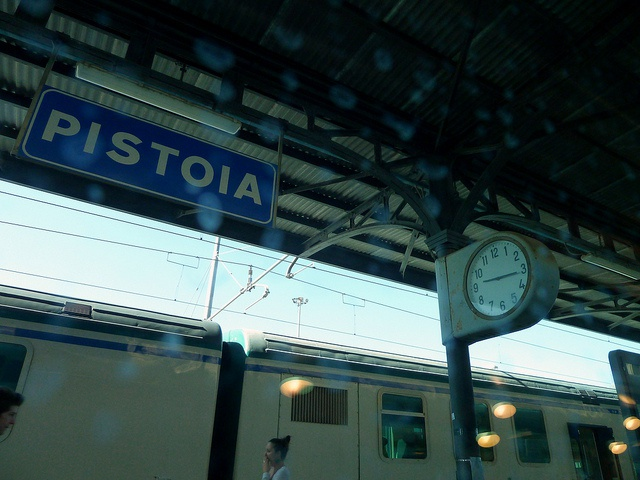Describe the objects in this image and their specific colors. I can see train in black, teal, and darkgreen tones, clock in black and teal tones, people in black, gray, and teal tones, and people in black and teal tones in this image. 